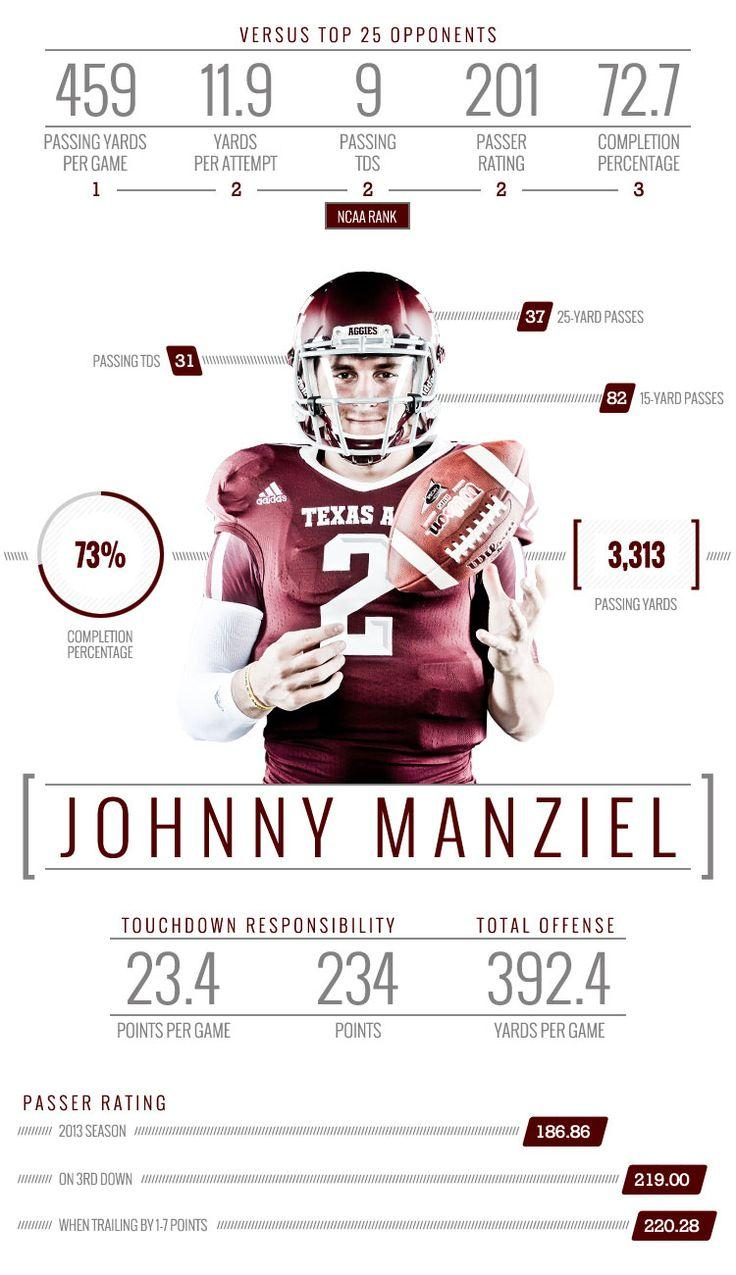Outline some significant characteristics in this image. The number written on the player's jersey is 2. 